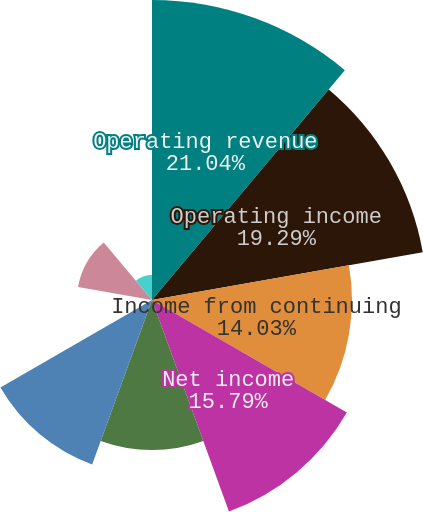Convert chart. <chart><loc_0><loc_0><loc_500><loc_500><pie_chart><fcel>Operating revenue<fcel>Operating income<fcel>Income from continuing<fcel>Net income<fcel>Net income attributable to CMS<fcel>Net income available to common<fcel>Earnings from continuing<fcel>Basic earnings per average<fcel>Diluted earnings per average<nl><fcel>21.05%<fcel>19.29%<fcel>14.03%<fcel>15.79%<fcel>10.53%<fcel>12.28%<fcel>0.01%<fcel>5.27%<fcel>1.76%<nl></chart> 